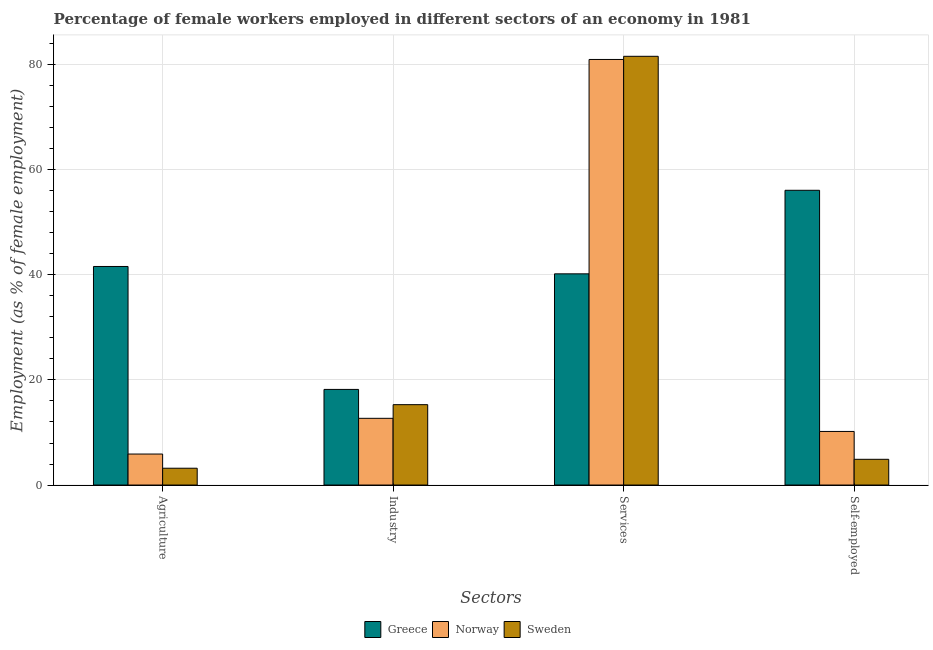How many groups of bars are there?
Provide a succinct answer. 4. Are the number of bars per tick equal to the number of legend labels?
Offer a very short reply. Yes. Are the number of bars on each tick of the X-axis equal?
Give a very brief answer. Yes. How many bars are there on the 3rd tick from the right?
Your response must be concise. 3. What is the label of the 4th group of bars from the left?
Make the answer very short. Self-employed. What is the percentage of female workers in agriculture in Greece?
Make the answer very short. 41.6. Across all countries, what is the maximum percentage of female workers in industry?
Make the answer very short. 18.2. Across all countries, what is the minimum percentage of female workers in services?
Offer a terse response. 40.2. In which country was the percentage of female workers in agriculture maximum?
Your answer should be very brief. Greece. In which country was the percentage of female workers in services minimum?
Give a very brief answer. Greece. What is the total percentage of female workers in industry in the graph?
Give a very brief answer. 46.2. What is the difference between the percentage of female workers in services in Sweden and that in Norway?
Offer a terse response. 0.6. What is the difference between the percentage of female workers in industry in Greece and the percentage of female workers in agriculture in Norway?
Offer a very short reply. 12.3. What is the average percentage of female workers in services per country?
Provide a succinct answer. 67.6. What is the difference between the percentage of female workers in agriculture and percentage of female workers in services in Greece?
Your answer should be very brief. 1.4. What is the ratio of the percentage of self employed female workers in Sweden to that in Norway?
Provide a succinct answer. 0.48. Is the percentage of self employed female workers in Sweden less than that in Greece?
Offer a terse response. Yes. What is the difference between the highest and the second highest percentage of female workers in services?
Ensure brevity in your answer.  0.6. What is the difference between the highest and the lowest percentage of female workers in industry?
Give a very brief answer. 5.5. Is it the case that in every country, the sum of the percentage of female workers in industry and percentage of self employed female workers is greater than the sum of percentage of female workers in agriculture and percentage of female workers in services?
Ensure brevity in your answer.  Yes. What does the 2nd bar from the right in Industry represents?
Your answer should be compact. Norway. Is it the case that in every country, the sum of the percentage of female workers in agriculture and percentage of female workers in industry is greater than the percentage of female workers in services?
Give a very brief answer. No. How many countries are there in the graph?
Your answer should be very brief. 3. What is the difference between two consecutive major ticks on the Y-axis?
Provide a succinct answer. 20. Are the values on the major ticks of Y-axis written in scientific E-notation?
Provide a short and direct response. No. Where does the legend appear in the graph?
Provide a short and direct response. Bottom center. How many legend labels are there?
Keep it short and to the point. 3. What is the title of the graph?
Your answer should be compact. Percentage of female workers employed in different sectors of an economy in 1981. What is the label or title of the X-axis?
Provide a succinct answer. Sectors. What is the label or title of the Y-axis?
Offer a very short reply. Employment (as % of female employment). What is the Employment (as % of female employment) of Greece in Agriculture?
Provide a short and direct response. 41.6. What is the Employment (as % of female employment) in Norway in Agriculture?
Provide a succinct answer. 5.9. What is the Employment (as % of female employment) of Sweden in Agriculture?
Ensure brevity in your answer.  3.2. What is the Employment (as % of female employment) of Greece in Industry?
Provide a succinct answer. 18.2. What is the Employment (as % of female employment) in Norway in Industry?
Provide a succinct answer. 12.7. What is the Employment (as % of female employment) of Sweden in Industry?
Your answer should be very brief. 15.3. What is the Employment (as % of female employment) in Greece in Services?
Your response must be concise. 40.2. What is the Employment (as % of female employment) in Sweden in Services?
Offer a very short reply. 81.6. What is the Employment (as % of female employment) in Greece in Self-employed?
Your answer should be very brief. 56.1. What is the Employment (as % of female employment) in Norway in Self-employed?
Offer a terse response. 10.2. What is the Employment (as % of female employment) of Sweden in Self-employed?
Give a very brief answer. 4.9. Across all Sectors, what is the maximum Employment (as % of female employment) in Greece?
Provide a short and direct response. 56.1. Across all Sectors, what is the maximum Employment (as % of female employment) of Sweden?
Your response must be concise. 81.6. Across all Sectors, what is the minimum Employment (as % of female employment) of Greece?
Give a very brief answer. 18.2. Across all Sectors, what is the minimum Employment (as % of female employment) of Norway?
Ensure brevity in your answer.  5.9. Across all Sectors, what is the minimum Employment (as % of female employment) in Sweden?
Give a very brief answer. 3.2. What is the total Employment (as % of female employment) of Greece in the graph?
Offer a very short reply. 156.1. What is the total Employment (as % of female employment) in Norway in the graph?
Your response must be concise. 109.8. What is the total Employment (as % of female employment) in Sweden in the graph?
Offer a very short reply. 105. What is the difference between the Employment (as % of female employment) in Greece in Agriculture and that in Industry?
Ensure brevity in your answer.  23.4. What is the difference between the Employment (as % of female employment) in Greece in Agriculture and that in Services?
Offer a terse response. 1.4. What is the difference between the Employment (as % of female employment) of Norway in Agriculture and that in Services?
Your response must be concise. -75.1. What is the difference between the Employment (as % of female employment) in Sweden in Agriculture and that in Services?
Offer a terse response. -78.4. What is the difference between the Employment (as % of female employment) of Sweden in Agriculture and that in Self-employed?
Your answer should be compact. -1.7. What is the difference between the Employment (as % of female employment) of Greece in Industry and that in Services?
Your answer should be very brief. -22. What is the difference between the Employment (as % of female employment) in Norway in Industry and that in Services?
Your response must be concise. -68.3. What is the difference between the Employment (as % of female employment) of Sweden in Industry and that in Services?
Provide a succinct answer. -66.3. What is the difference between the Employment (as % of female employment) of Greece in Industry and that in Self-employed?
Keep it short and to the point. -37.9. What is the difference between the Employment (as % of female employment) of Norway in Industry and that in Self-employed?
Keep it short and to the point. 2.5. What is the difference between the Employment (as % of female employment) of Sweden in Industry and that in Self-employed?
Your answer should be very brief. 10.4. What is the difference between the Employment (as % of female employment) of Greece in Services and that in Self-employed?
Your answer should be very brief. -15.9. What is the difference between the Employment (as % of female employment) in Norway in Services and that in Self-employed?
Keep it short and to the point. 70.8. What is the difference between the Employment (as % of female employment) in Sweden in Services and that in Self-employed?
Offer a terse response. 76.7. What is the difference between the Employment (as % of female employment) in Greece in Agriculture and the Employment (as % of female employment) in Norway in Industry?
Your answer should be very brief. 28.9. What is the difference between the Employment (as % of female employment) of Greece in Agriculture and the Employment (as % of female employment) of Sweden in Industry?
Your answer should be compact. 26.3. What is the difference between the Employment (as % of female employment) in Greece in Agriculture and the Employment (as % of female employment) in Norway in Services?
Your answer should be very brief. -39.4. What is the difference between the Employment (as % of female employment) in Greece in Agriculture and the Employment (as % of female employment) in Sweden in Services?
Keep it short and to the point. -40. What is the difference between the Employment (as % of female employment) in Norway in Agriculture and the Employment (as % of female employment) in Sweden in Services?
Offer a terse response. -75.7. What is the difference between the Employment (as % of female employment) of Greece in Agriculture and the Employment (as % of female employment) of Norway in Self-employed?
Keep it short and to the point. 31.4. What is the difference between the Employment (as % of female employment) of Greece in Agriculture and the Employment (as % of female employment) of Sweden in Self-employed?
Your answer should be very brief. 36.7. What is the difference between the Employment (as % of female employment) in Norway in Agriculture and the Employment (as % of female employment) in Sweden in Self-employed?
Give a very brief answer. 1. What is the difference between the Employment (as % of female employment) of Greece in Industry and the Employment (as % of female employment) of Norway in Services?
Make the answer very short. -62.8. What is the difference between the Employment (as % of female employment) in Greece in Industry and the Employment (as % of female employment) in Sweden in Services?
Provide a short and direct response. -63.4. What is the difference between the Employment (as % of female employment) of Norway in Industry and the Employment (as % of female employment) of Sweden in Services?
Keep it short and to the point. -68.9. What is the difference between the Employment (as % of female employment) in Greece in Industry and the Employment (as % of female employment) in Norway in Self-employed?
Your answer should be compact. 8. What is the difference between the Employment (as % of female employment) of Greece in Industry and the Employment (as % of female employment) of Sweden in Self-employed?
Your answer should be compact. 13.3. What is the difference between the Employment (as % of female employment) in Norway in Industry and the Employment (as % of female employment) in Sweden in Self-employed?
Offer a very short reply. 7.8. What is the difference between the Employment (as % of female employment) in Greece in Services and the Employment (as % of female employment) in Norway in Self-employed?
Your response must be concise. 30. What is the difference between the Employment (as % of female employment) of Greece in Services and the Employment (as % of female employment) of Sweden in Self-employed?
Make the answer very short. 35.3. What is the difference between the Employment (as % of female employment) of Norway in Services and the Employment (as % of female employment) of Sweden in Self-employed?
Provide a succinct answer. 76.1. What is the average Employment (as % of female employment) of Greece per Sectors?
Provide a succinct answer. 39.02. What is the average Employment (as % of female employment) of Norway per Sectors?
Your answer should be very brief. 27.45. What is the average Employment (as % of female employment) of Sweden per Sectors?
Your answer should be compact. 26.25. What is the difference between the Employment (as % of female employment) of Greece and Employment (as % of female employment) of Norway in Agriculture?
Give a very brief answer. 35.7. What is the difference between the Employment (as % of female employment) in Greece and Employment (as % of female employment) in Sweden in Agriculture?
Keep it short and to the point. 38.4. What is the difference between the Employment (as % of female employment) in Norway and Employment (as % of female employment) in Sweden in Industry?
Provide a succinct answer. -2.6. What is the difference between the Employment (as % of female employment) of Greece and Employment (as % of female employment) of Norway in Services?
Make the answer very short. -40.8. What is the difference between the Employment (as % of female employment) of Greece and Employment (as % of female employment) of Sweden in Services?
Ensure brevity in your answer.  -41.4. What is the difference between the Employment (as % of female employment) of Norway and Employment (as % of female employment) of Sweden in Services?
Give a very brief answer. -0.6. What is the difference between the Employment (as % of female employment) of Greece and Employment (as % of female employment) of Norway in Self-employed?
Offer a very short reply. 45.9. What is the difference between the Employment (as % of female employment) of Greece and Employment (as % of female employment) of Sweden in Self-employed?
Ensure brevity in your answer.  51.2. What is the difference between the Employment (as % of female employment) in Norway and Employment (as % of female employment) in Sweden in Self-employed?
Provide a succinct answer. 5.3. What is the ratio of the Employment (as % of female employment) of Greece in Agriculture to that in Industry?
Provide a succinct answer. 2.29. What is the ratio of the Employment (as % of female employment) of Norway in Agriculture to that in Industry?
Keep it short and to the point. 0.46. What is the ratio of the Employment (as % of female employment) in Sweden in Agriculture to that in Industry?
Offer a terse response. 0.21. What is the ratio of the Employment (as % of female employment) in Greece in Agriculture to that in Services?
Make the answer very short. 1.03. What is the ratio of the Employment (as % of female employment) in Norway in Agriculture to that in Services?
Make the answer very short. 0.07. What is the ratio of the Employment (as % of female employment) of Sweden in Agriculture to that in Services?
Your answer should be very brief. 0.04. What is the ratio of the Employment (as % of female employment) in Greece in Agriculture to that in Self-employed?
Your answer should be compact. 0.74. What is the ratio of the Employment (as % of female employment) in Norway in Agriculture to that in Self-employed?
Keep it short and to the point. 0.58. What is the ratio of the Employment (as % of female employment) of Sweden in Agriculture to that in Self-employed?
Provide a succinct answer. 0.65. What is the ratio of the Employment (as % of female employment) of Greece in Industry to that in Services?
Your answer should be very brief. 0.45. What is the ratio of the Employment (as % of female employment) in Norway in Industry to that in Services?
Make the answer very short. 0.16. What is the ratio of the Employment (as % of female employment) in Sweden in Industry to that in Services?
Offer a very short reply. 0.19. What is the ratio of the Employment (as % of female employment) of Greece in Industry to that in Self-employed?
Your response must be concise. 0.32. What is the ratio of the Employment (as % of female employment) in Norway in Industry to that in Self-employed?
Provide a short and direct response. 1.25. What is the ratio of the Employment (as % of female employment) in Sweden in Industry to that in Self-employed?
Give a very brief answer. 3.12. What is the ratio of the Employment (as % of female employment) in Greece in Services to that in Self-employed?
Keep it short and to the point. 0.72. What is the ratio of the Employment (as % of female employment) in Norway in Services to that in Self-employed?
Your answer should be compact. 7.94. What is the ratio of the Employment (as % of female employment) of Sweden in Services to that in Self-employed?
Ensure brevity in your answer.  16.65. What is the difference between the highest and the second highest Employment (as % of female employment) in Greece?
Give a very brief answer. 14.5. What is the difference between the highest and the second highest Employment (as % of female employment) of Norway?
Ensure brevity in your answer.  68.3. What is the difference between the highest and the second highest Employment (as % of female employment) in Sweden?
Provide a succinct answer. 66.3. What is the difference between the highest and the lowest Employment (as % of female employment) of Greece?
Provide a short and direct response. 37.9. What is the difference between the highest and the lowest Employment (as % of female employment) in Norway?
Your answer should be very brief. 75.1. What is the difference between the highest and the lowest Employment (as % of female employment) in Sweden?
Give a very brief answer. 78.4. 